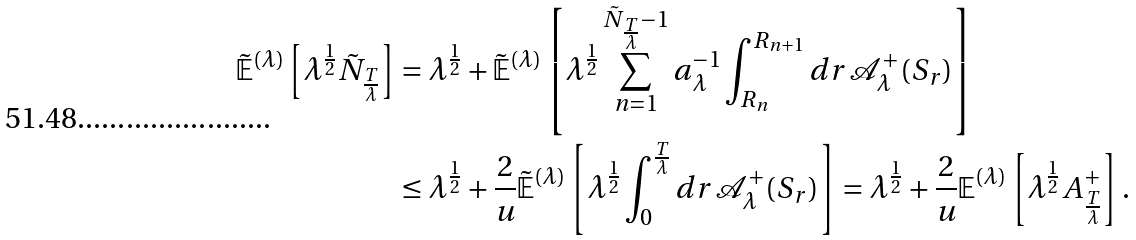Convert formula to latex. <formula><loc_0><loc_0><loc_500><loc_500>\tilde { \mathbb { E } } ^ { ( \lambda ) } \left [ \lambda ^ { \frac { 1 } { 2 } } \tilde { N } _ { \frac { T } { \lambda } } \right ] & = \lambda ^ { \frac { 1 } { 2 } } + \tilde { \mathbb { E } } ^ { ( \lambda ) } \left [ \lambda ^ { \frac { 1 } { 2 } } \sum _ { n = 1 } ^ { \tilde { N } _ { \frac { T } { \lambda } } - 1 } a _ { \lambda } ^ { - 1 } \int _ { R _ { n } } ^ { R _ { n + 1 } } d r \, \mathcal { A } _ { \lambda } ^ { + } ( S _ { r } ) \right ] \\ & \leq \lambda ^ { \frac { 1 } { 2 } } + \frac { 2 } { u } \tilde { \mathbb { E } } ^ { ( \lambda ) } \left [ \lambda ^ { \frac { 1 } { 2 } } \int _ { 0 } ^ { \frac { T } { \lambda } } d r \, \mathcal { A } _ { \lambda } ^ { + } ( S _ { r } ) \right ] = \lambda ^ { \frac { 1 } { 2 } } + \frac { 2 } { u } \mathbb { E } ^ { ( \lambda ) } \left [ \lambda ^ { \frac { 1 } { 2 } } A _ { \frac { T } { \lambda } } ^ { + } \right ] .</formula> 